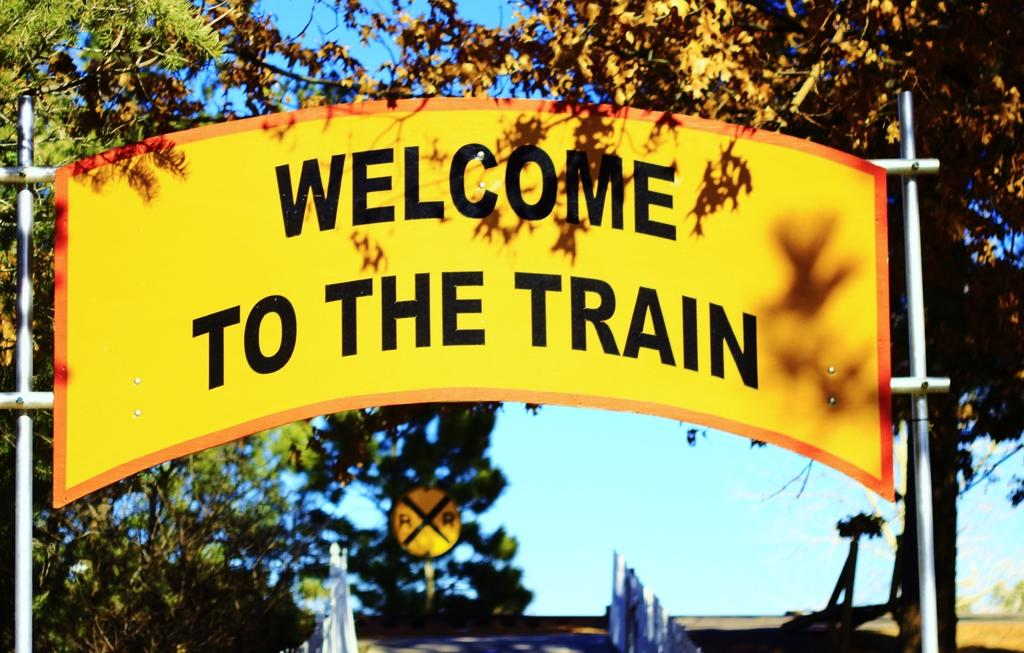What is the main object in the image? There is a signboard pole in the image. What can be seen on the left side of the image? There are trees on the left side of the image. What can be seen on the right side of the image? There are trees on the right side of the image. What type of fang can be seen hanging from the signboard pole in the image? There is no fang present on the signboard pole in the image. How many soldiers are visible in the image? There are no soldiers or army-related elements present in the image. 